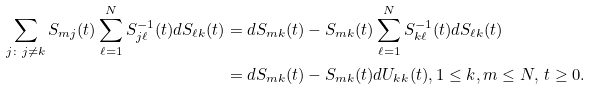Convert formula to latex. <formula><loc_0><loc_0><loc_500><loc_500>\sum _ { j \colon j \neq k } S _ { m j } ( t ) \sum _ { \ell = 1 } ^ { N } S ^ { - 1 } _ { j \ell } ( t ) d S _ { \ell k } ( t ) & = d S _ { m k } ( t ) - S _ { m k } ( t ) \sum _ { \ell = 1 } ^ { N } S ^ { - 1 } _ { k \ell } ( t ) d S _ { \ell k } ( t ) \\ & = d S _ { m k } ( t ) - S _ { m k } ( t ) d U _ { k k } ( t ) , 1 \leq k , m \leq N , \, t \geq 0 .</formula> 